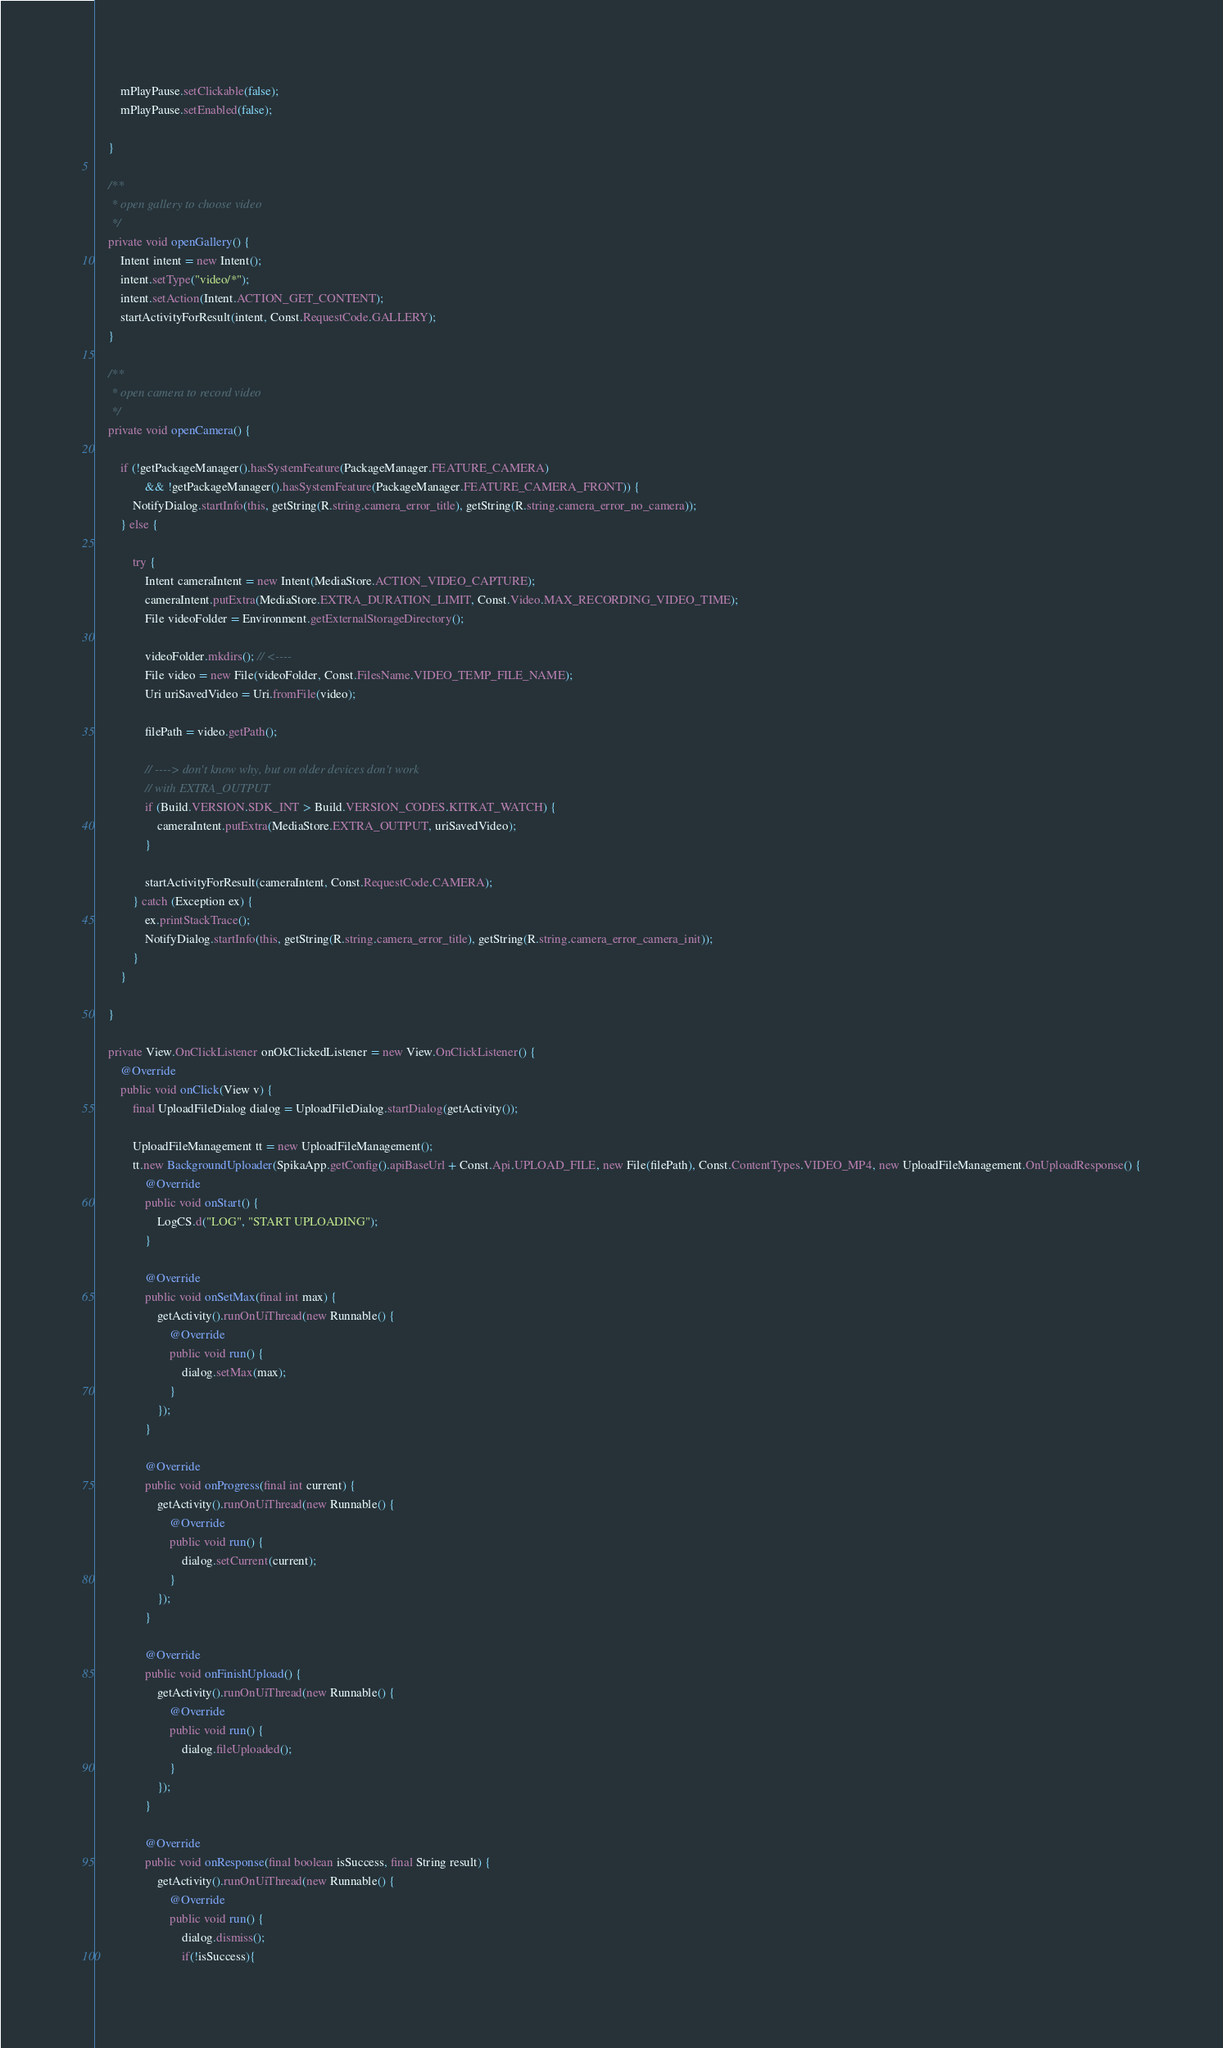<code> <loc_0><loc_0><loc_500><loc_500><_Java_>
        mPlayPause.setClickable(false);
        mPlayPause.setEnabled(false);

    }

    /**
     * open gallery to choose video
     */
    private void openGallery() {
        Intent intent = new Intent();
        intent.setType("video/*");
        intent.setAction(Intent.ACTION_GET_CONTENT);
        startActivityForResult(intent, Const.RequestCode.GALLERY);
    }

    /**
     * open camera to record video
     */
    private void openCamera() {

        if (!getPackageManager().hasSystemFeature(PackageManager.FEATURE_CAMERA)
                && !getPackageManager().hasSystemFeature(PackageManager.FEATURE_CAMERA_FRONT)) {
            NotifyDialog.startInfo(this, getString(R.string.camera_error_title), getString(R.string.camera_error_no_camera));
        } else {

            try {
                Intent cameraIntent = new Intent(MediaStore.ACTION_VIDEO_CAPTURE);
                cameraIntent.putExtra(MediaStore.EXTRA_DURATION_LIMIT, Const.Video.MAX_RECORDING_VIDEO_TIME);
                File videoFolder = Environment.getExternalStorageDirectory();

                videoFolder.mkdirs(); // <----
                File video = new File(videoFolder, Const.FilesName.VIDEO_TEMP_FILE_NAME);
                Uri uriSavedVideo = Uri.fromFile(video);

                filePath = video.getPath();

                // ----> don't know why, but on older devices don't work
                // with EXTRA_OUTPUT
                if (Build.VERSION.SDK_INT > Build.VERSION_CODES.KITKAT_WATCH) {
                    cameraIntent.putExtra(MediaStore.EXTRA_OUTPUT, uriSavedVideo);
                }

                startActivityForResult(cameraIntent, Const.RequestCode.CAMERA);
            } catch (Exception ex) {
                ex.printStackTrace();
                NotifyDialog.startInfo(this, getString(R.string.camera_error_title), getString(R.string.camera_error_camera_init));
            }
        }

    }

    private View.OnClickListener onOkClickedListener = new View.OnClickListener() {
        @Override
        public void onClick(View v) {
            final UploadFileDialog dialog = UploadFileDialog.startDialog(getActivity());

            UploadFileManagement tt = new UploadFileManagement();
            tt.new BackgroundUploader(SpikaApp.getConfig().apiBaseUrl + Const.Api.UPLOAD_FILE, new File(filePath), Const.ContentTypes.VIDEO_MP4, new UploadFileManagement.OnUploadResponse() {
                @Override
                public void onStart() {
                    LogCS.d("LOG", "START UPLOADING");
                }

                @Override
                public void onSetMax(final int max) {
                    getActivity().runOnUiThread(new Runnable() {
                        @Override
                        public void run() {
                            dialog.setMax(max);
                        }
                    });
                }

                @Override
                public void onProgress(final int current) {
                    getActivity().runOnUiThread(new Runnable() {
                        @Override
                        public void run() {
                            dialog.setCurrent(current);
                        }
                    });
                }

                @Override
                public void onFinishUpload() {
                    getActivity().runOnUiThread(new Runnable() {
                        @Override
                        public void run() {
                            dialog.fileUploaded();
                        }
                    });
                }

                @Override
                public void onResponse(final boolean isSuccess, final String result) {
                    getActivity().runOnUiThread(new Runnable() {
                        @Override
                        public void run() {
                            dialog.dismiss();
                            if(!isSuccess){</code> 